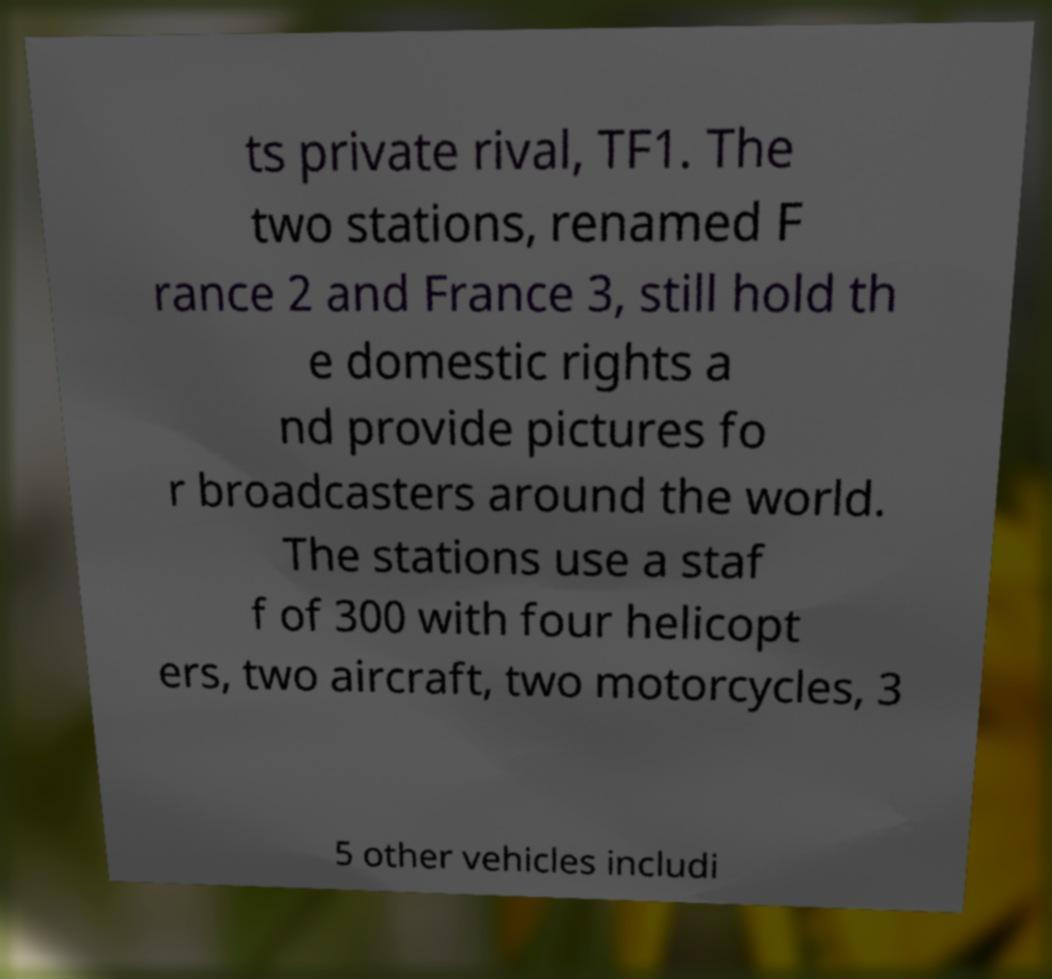Could you assist in decoding the text presented in this image and type it out clearly? ts private rival, TF1. The two stations, renamed F rance 2 and France 3, still hold th e domestic rights a nd provide pictures fo r broadcasters around the world. The stations use a staf f of 300 with four helicopt ers, two aircraft, two motorcycles, 3 5 other vehicles includi 